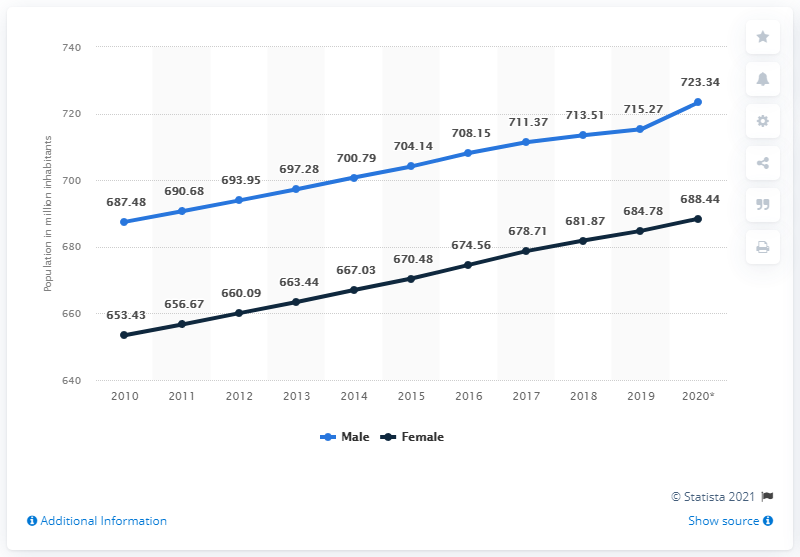Highlight a few significant elements in this photo. In 2020, approximately 723.34 million males lived in China. The maximum increase in the value of the blue line was observed in 2020. In 2020, there were approximately 688.44 females living in China. The male population in China did not decrease at any time between 2010 and 2020. 